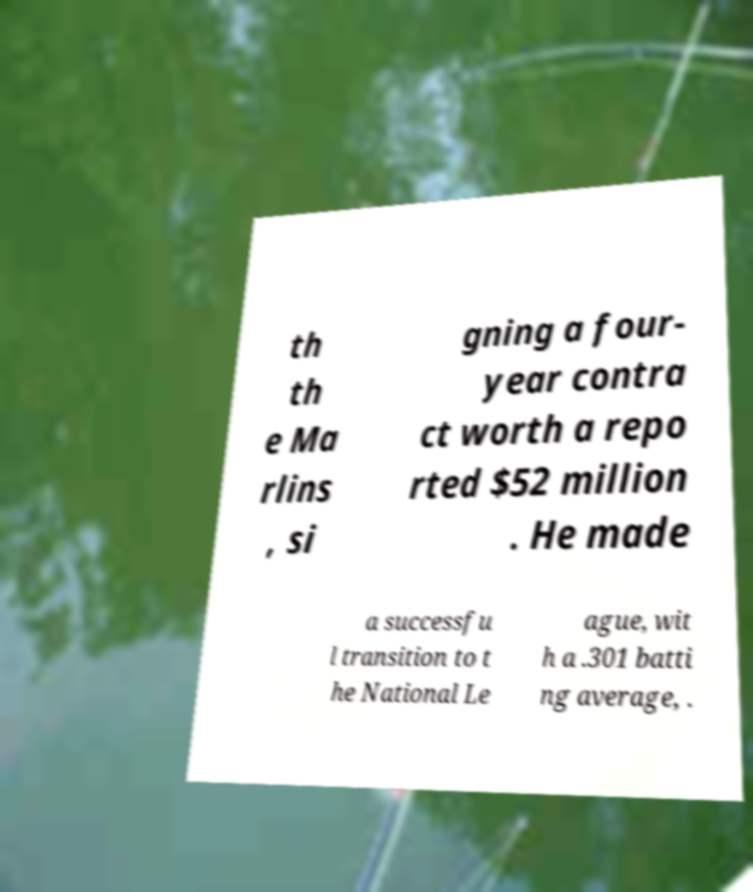Could you extract and type out the text from this image? th th e Ma rlins , si gning a four- year contra ct worth a repo rted $52 million . He made a successfu l transition to t he National Le ague, wit h a .301 batti ng average, . 